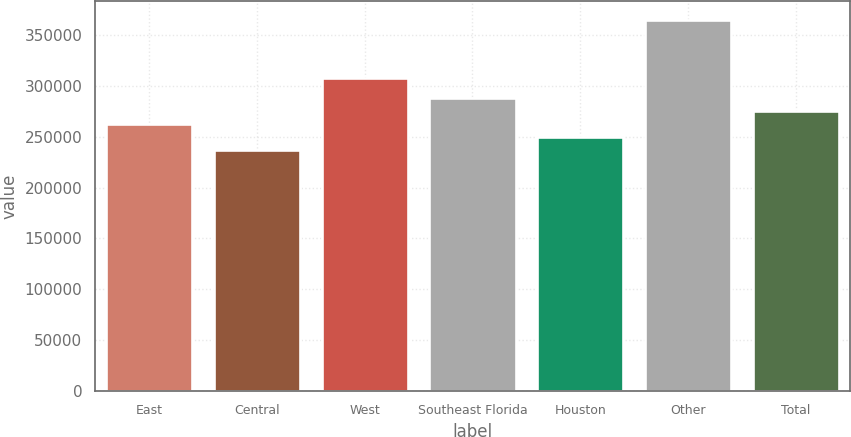Convert chart. <chart><loc_0><loc_0><loc_500><loc_500><bar_chart><fcel>East<fcel>Central<fcel>West<fcel>Southeast Florida<fcel>Houston<fcel>Other<fcel>Total<nl><fcel>262600<fcel>237000<fcel>308000<fcel>288200<fcel>249800<fcel>365000<fcel>275400<nl></chart> 